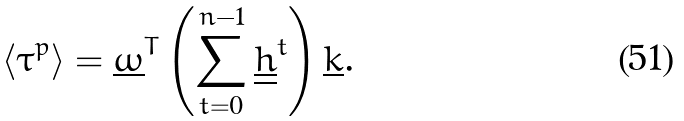<formula> <loc_0><loc_0><loc_500><loc_500>\left < \tau ^ { p } \right > = \underline { \omega } ^ { T } \left ( \sum _ { t = 0 } ^ { n - 1 } \underline { \underline { h } } ^ { t } \right ) \underline { k } .</formula> 